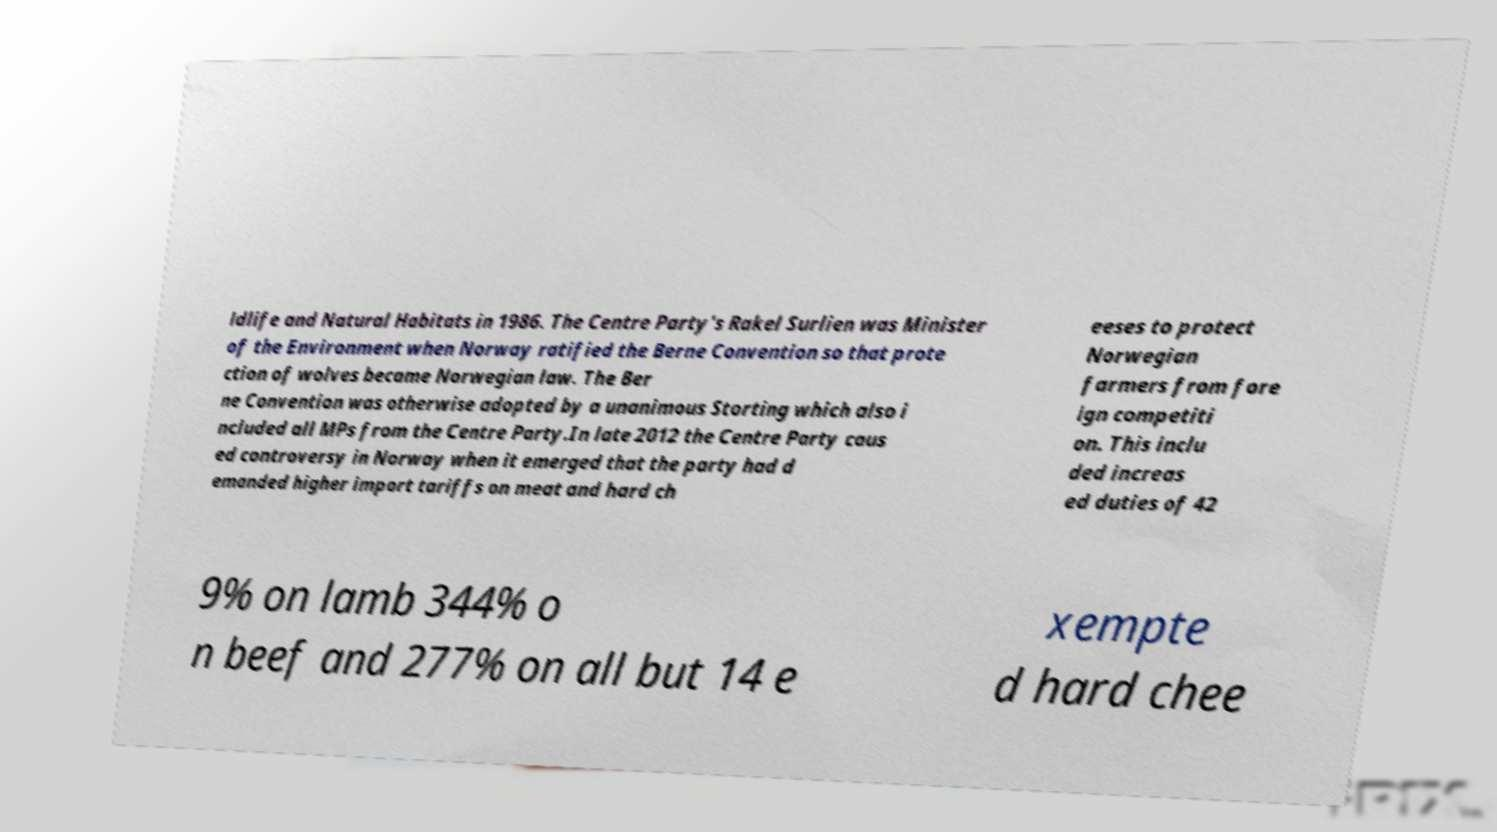Could you extract and type out the text from this image? ldlife and Natural Habitats in 1986. The Centre Party's Rakel Surlien was Minister of the Environment when Norway ratified the Berne Convention so that prote ction of wolves became Norwegian law. The Ber ne Convention was otherwise adopted by a unanimous Storting which also i ncluded all MPs from the Centre Party.In late 2012 the Centre Party caus ed controversy in Norway when it emerged that the party had d emanded higher import tariffs on meat and hard ch eeses to protect Norwegian farmers from fore ign competiti on. This inclu ded increas ed duties of 42 9% on lamb 344% o n beef and 277% on all but 14 e xempte d hard chee 